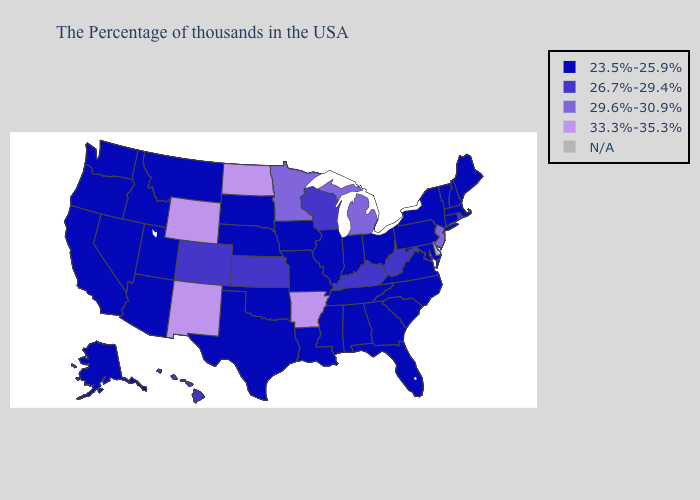What is the value of Rhode Island?
Be succinct. 26.7%-29.4%. Name the states that have a value in the range 29.6%-30.9%?
Short answer required. New Jersey, Michigan, Minnesota. Name the states that have a value in the range 33.3%-35.3%?
Give a very brief answer. Arkansas, North Dakota, Wyoming, New Mexico. What is the highest value in states that border Georgia?
Short answer required. 23.5%-25.9%. Name the states that have a value in the range 23.5%-25.9%?
Be succinct. Maine, Massachusetts, New Hampshire, Vermont, Connecticut, New York, Maryland, Pennsylvania, Virginia, North Carolina, South Carolina, Ohio, Florida, Georgia, Indiana, Alabama, Tennessee, Illinois, Mississippi, Louisiana, Missouri, Iowa, Nebraska, Oklahoma, Texas, South Dakota, Utah, Montana, Arizona, Idaho, Nevada, California, Washington, Oregon, Alaska. Which states hav the highest value in the MidWest?
Quick response, please. North Dakota. What is the value of Arizona?
Keep it brief. 23.5%-25.9%. Does New Jersey have the highest value in the Northeast?
Be succinct. Yes. What is the value of New York?
Be succinct. 23.5%-25.9%. What is the value of Wyoming?
Concise answer only. 33.3%-35.3%. Name the states that have a value in the range 33.3%-35.3%?
Quick response, please. Arkansas, North Dakota, Wyoming, New Mexico. Does Arkansas have the lowest value in the South?
Write a very short answer. No. What is the highest value in the USA?
Write a very short answer. 33.3%-35.3%. 